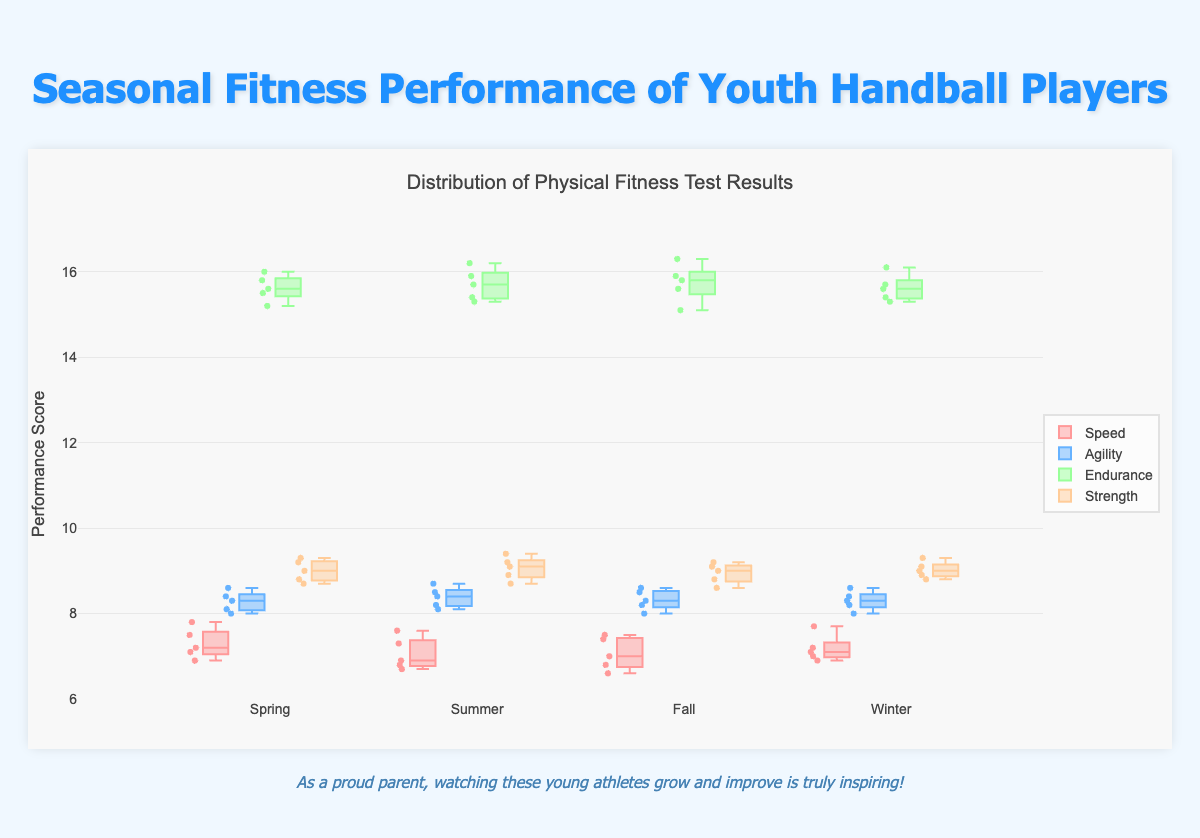What is the title of the figure? The title of the figure is located at the top, centered, in a larger font size. Reading it directly, we see "Seasonal Fitness Performance of Youth Handball Players."
Answer: Seasonal Fitness Performance of Youth Handball Players How many seasons are represented in the box plot? The box plot groups data by seasons, and looking at the x-axis, we see labels for four seasons: Spring, Summer, Fall, and Winter.
Answer: 4 Which fitness metric has the highest maximum value in Fall? By examining the upper whisker of each box in Fall, we note the highest vertical reach across metrics. The Endurance box reaches up to around 16.3, which is higher than any other metric.
Answer: Endurance What is the range of Speed scores in the Summer season? The range is found by subtracting the minimum value in the Speed box plot for Summer from the maximum value. Looking at the plot, we find min ~6.7 and max ~7.6, so the range is 7.6 - 6.7.
Answer: 0.9 Which season has the highest median Strength score? We find the median line inside the box plots of Strength for each season. The Winter box plot shows a higher median line (around 9.1) than the others.
Answer: Winter What is the interquartile range (IQR) of Agility in the Winter season? The IQR is the difference between the 75th and 25th percentiles. The box for Agility in Winter stretches from ~8.0 (Q1) to ~8.6 (Q3). IQR = 8.6 - 8.0.
Answer: 0.6 Which season has the most consistent Endurance performance (smallest interquartile range)? Consistency in performance relates to the box (interquartile range) size. The narrowest box for Endurance indicates consistency. Summer's IQR (~15.7 to ~15.3) is smallest.
Answer: Summer Is there a significant difference in the range of Strength scores between Spring and Winter? Comparing the range (max - min) of Strength: Spring ~9.0-8.7 = 0.3 and Winter ~9.3-8.8 = 0.5. The ranges differ, but not hugely.
Answer: No significant difference Do the box plots suggest any outliers for Agility in any season? Outliers are generally individual points outside the whiskers. There are no isolated points seen beyond the whiskers for Agility in any season.
Answer: No In which season did the Speed metric show the highest variability? Variability is reflected by the whiskers’ span and the box's height. Speed in Spring shows the highest variability with a more extended vertical distance from whisker to whisker.
Answer: Spring 